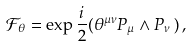<formula> <loc_0><loc_0><loc_500><loc_500>\mathcal { F } _ { \theta } = \exp \frac { i } { 2 } ( \theta ^ { \mu \nu } P _ { \mu } \wedge P _ { \nu } \, ) \, ,</formula> 